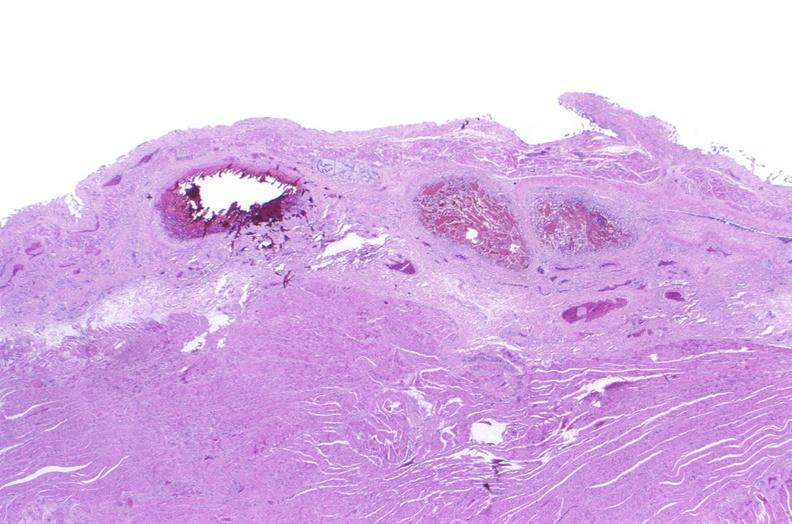s gastrointestinal present?
Answer the question using a single word or phrase. Yes 